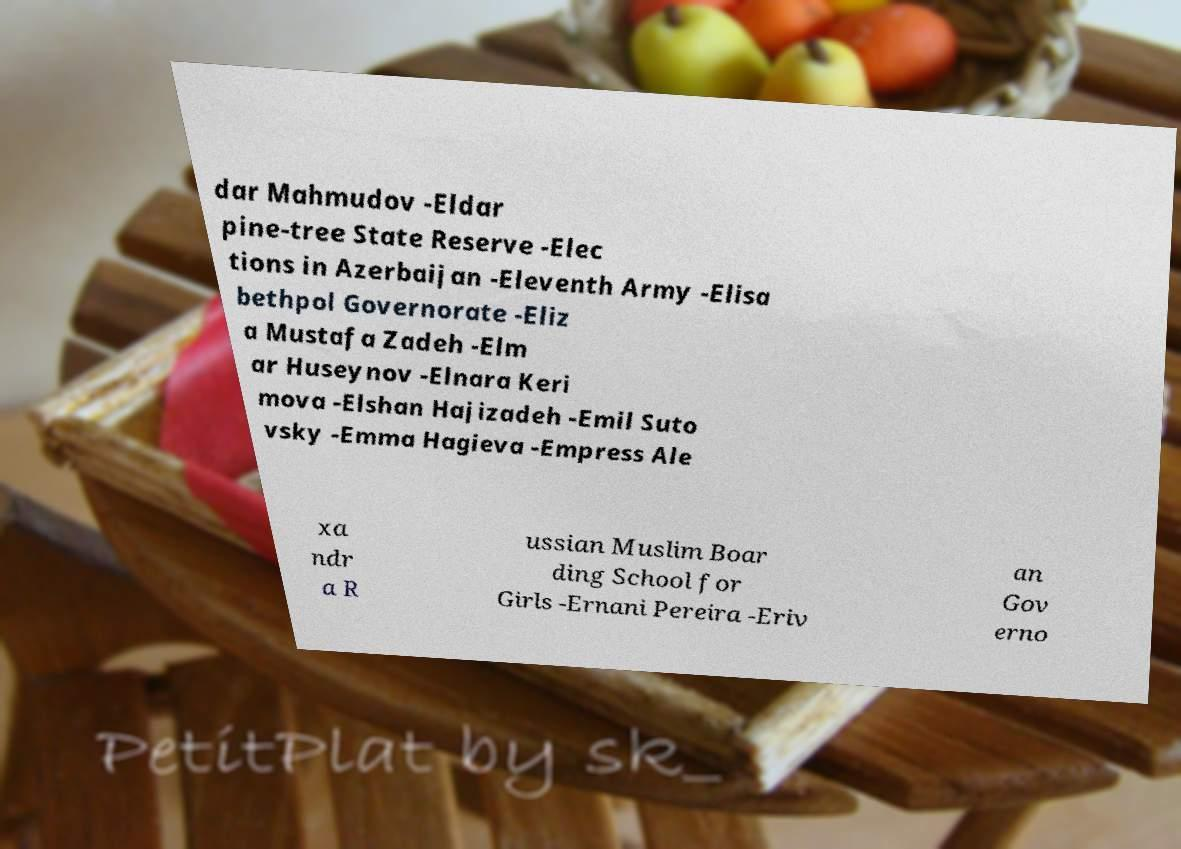Could you assist in decoding the text presented in this image and type it out clearly? dar Mahmudov -Eldar pine-tree State Reserve -Elec tions in Azerbaijan -Eleventh Army -Elisa bethpol Governorate -Eliz a Mustafa Zadeh -Elm ar Huseynov -Elnara Keri mova -Elshan Hajizadeh -Emil Suto vsky -Emma Hagieva -Empress Ale xa ndr a R ussian Muslim Boar ding School for Girls -Ernani Pereira -Eriv an Gov erno 